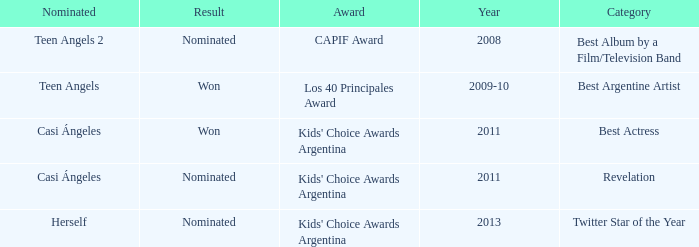What year saw an award in the category of Revelation? 2011.0. 